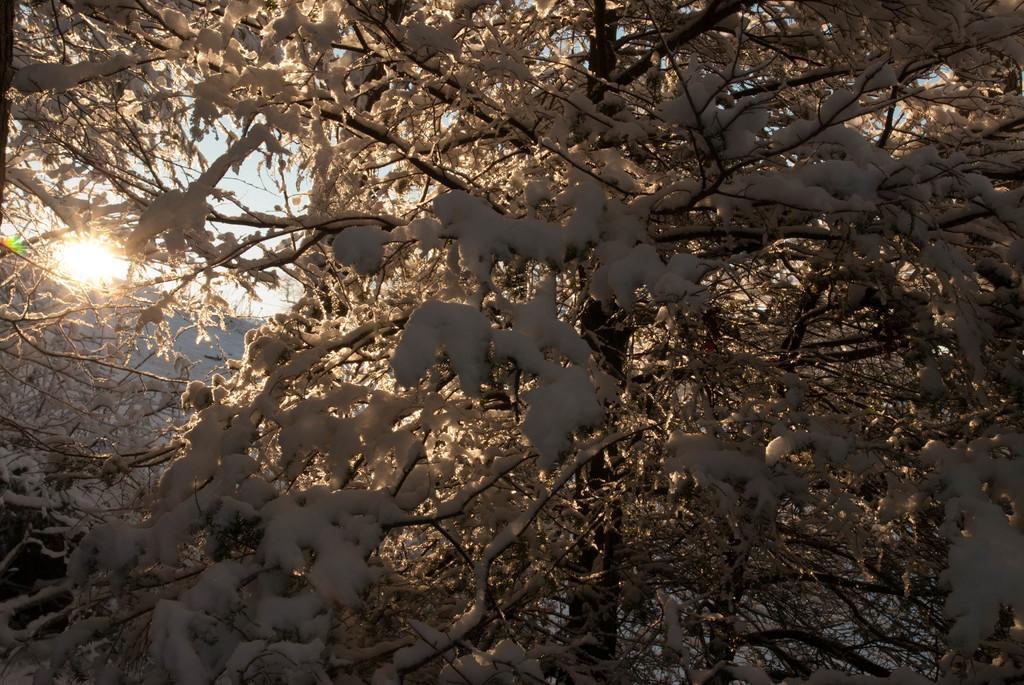In one or two sentences, can you explain what this image depicts? In this picture we can see a tree in the front, we can see snow on the branches of the tree, in the background we can see the sky. 